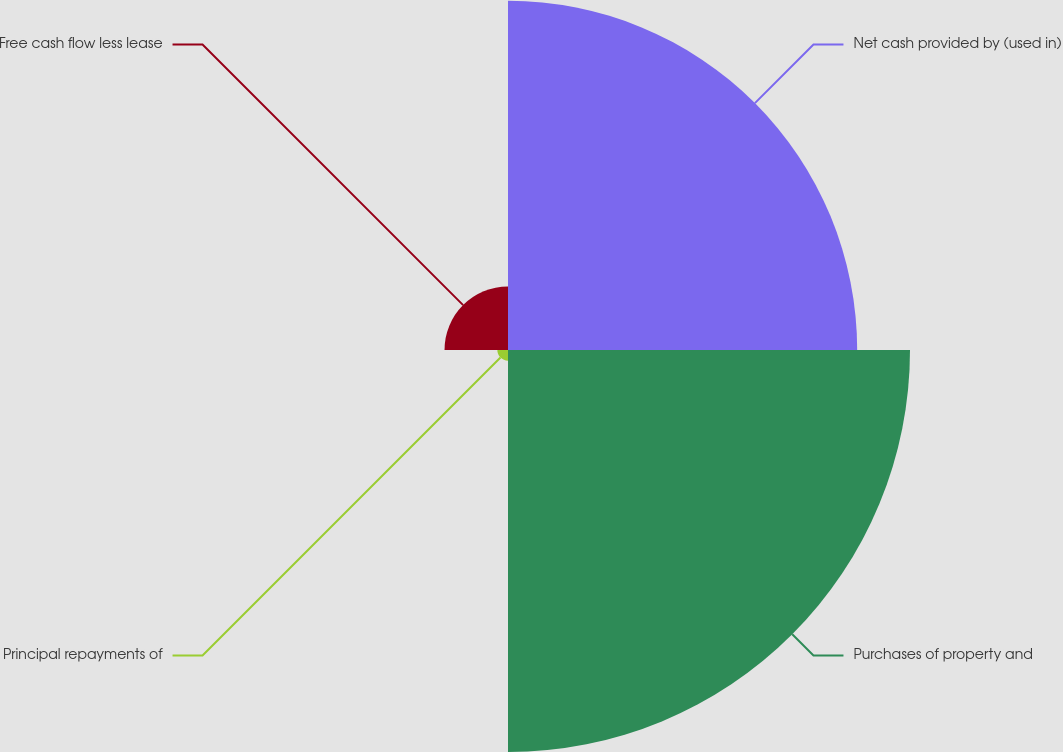Convert chart to OTSL. <chart><loc_0><loc_0><loc_500><loc_500><pie_chart><fcel>Net cash provided by (used in)<fcel>Purchases of property and<fcel>Principal repayments of<fcel>Free cash flow less lease<nl><fcel>42.31%<fcel>48.71%<fcel>1.29%<fcel>7.69%<nl></chart> 